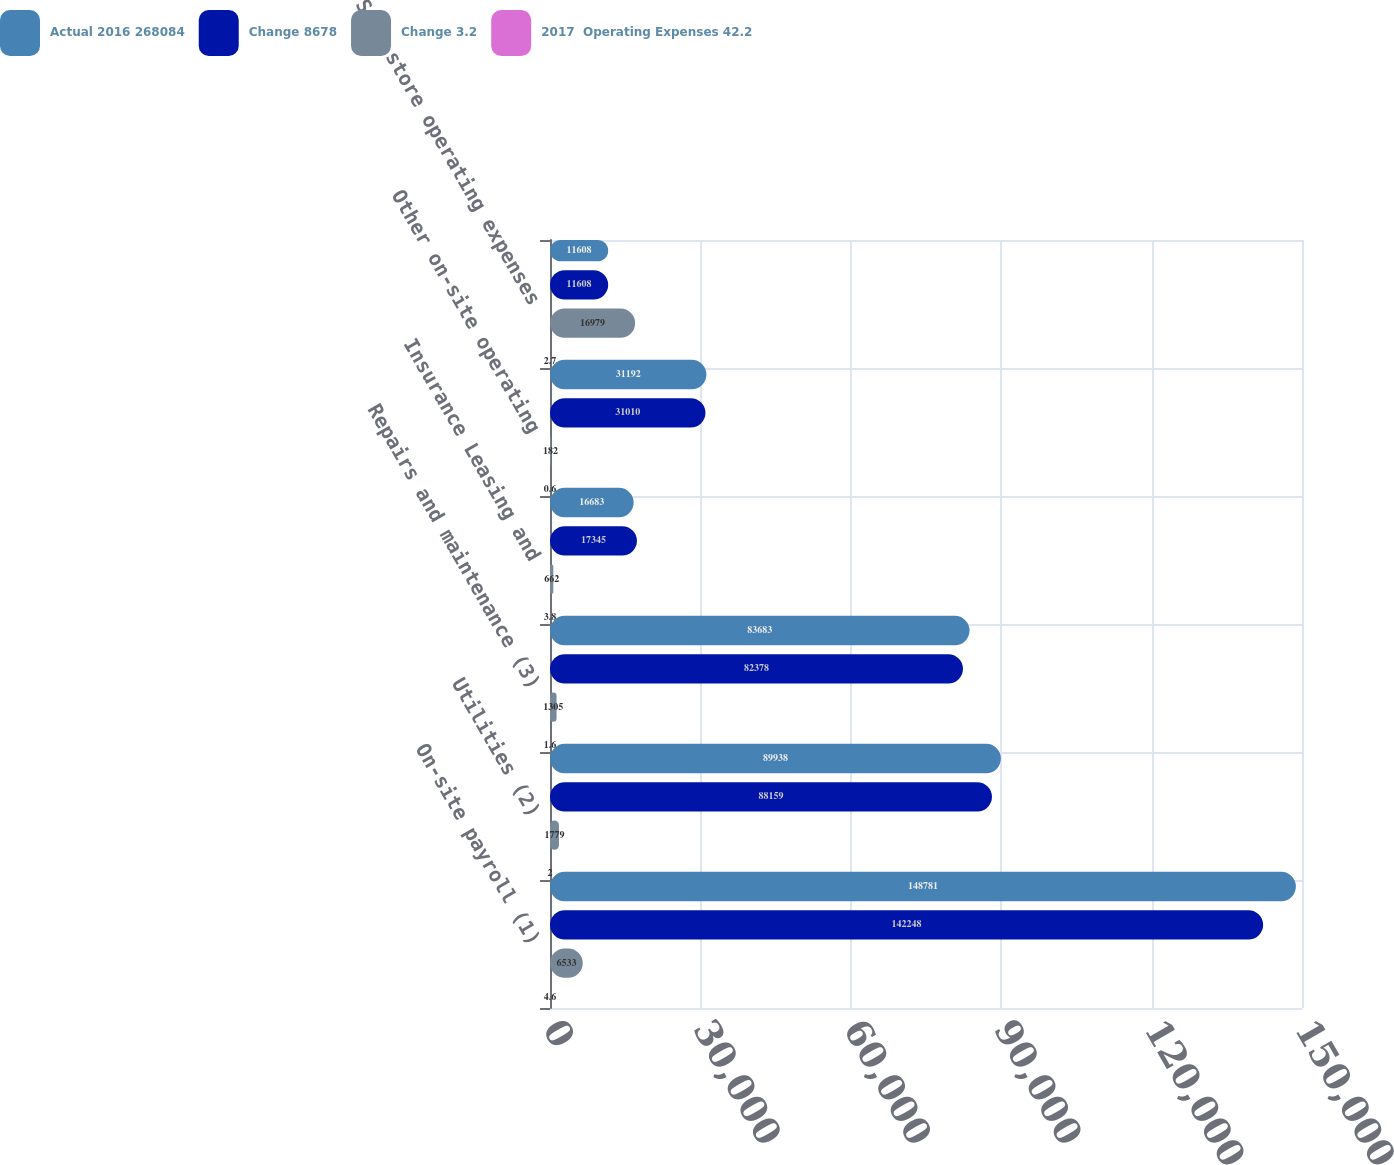Convert chart. <chart><loc_0><loc_0><loc_500><loc_500><stacked_bar_chart><ecel><fcel>On-site payroll (1)<fcel>Utilities (2)<fcel>Repairs and maintenance (3)<fcel>Insurance Leasing and<fcel>Other on-site operating<fcel>Same store operating expenses<nl><fcel>Actual 2016 268084<fcel>148781<fcel>89938<fcel>83683<fcel>16683<fcel>31192<fcel>11608<nl><fcel>Change 8678<fcel>142248<fcel>88159<fcel>82378<fcel>17345<fcel>31010<fcel>11608<nl><fcel>Change 3.2<fcel>6533<fcel>1779<fcel>1305<fcel>662<fcel>182<fcel>16979<nl><fcel>2017  Operating Expenses 42.2<fcel>4.6<fcel>2<fcel>1.6<fcel>3.8<fcel>0.6<fcel>2.7<nl></chart> 